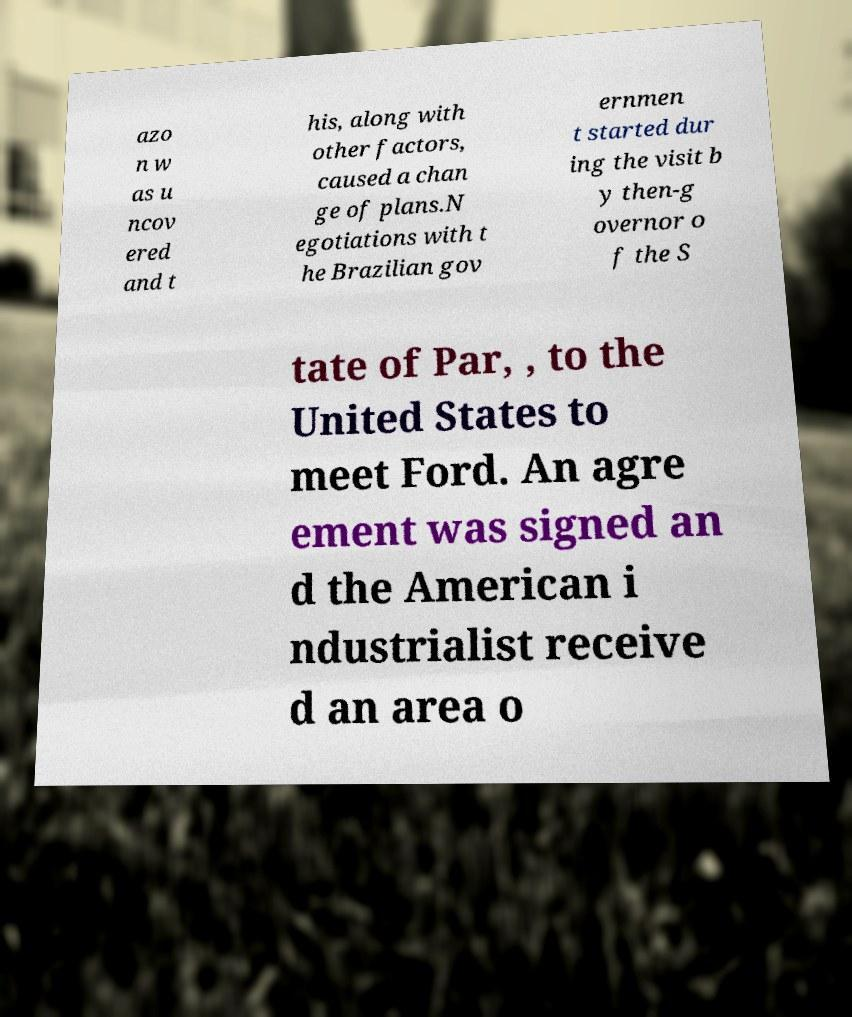Please identify and transcribe the text found in this image. azo n w as u ncov ered and t his, along with other factors, caused a chan ge of plans.N egotiations with t he Brazilian gov ernmen t started dur ing the visit b y then-g overnor o f the S tate of Par, , to the United States to meet Ford. An agre ement was signed an d the American i ndustrialist receive d an area o 